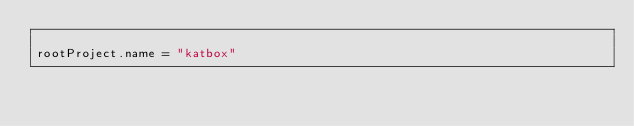Convert code to text. <code><loc_0><loc_0><loc_500><loc_500><_Kotlin_>
rootProject.name = "katbox"

</code> 